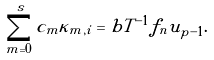Convert formula to latex. <formula><loc_0><loc_0><loc_500><loc_500>\sum _ { m = 0 } ^ { s } c _ { m } \kappa _ { m , i } = b T ^ { - 1 } f _ { n } u _ { p - 1 } .</formula> 